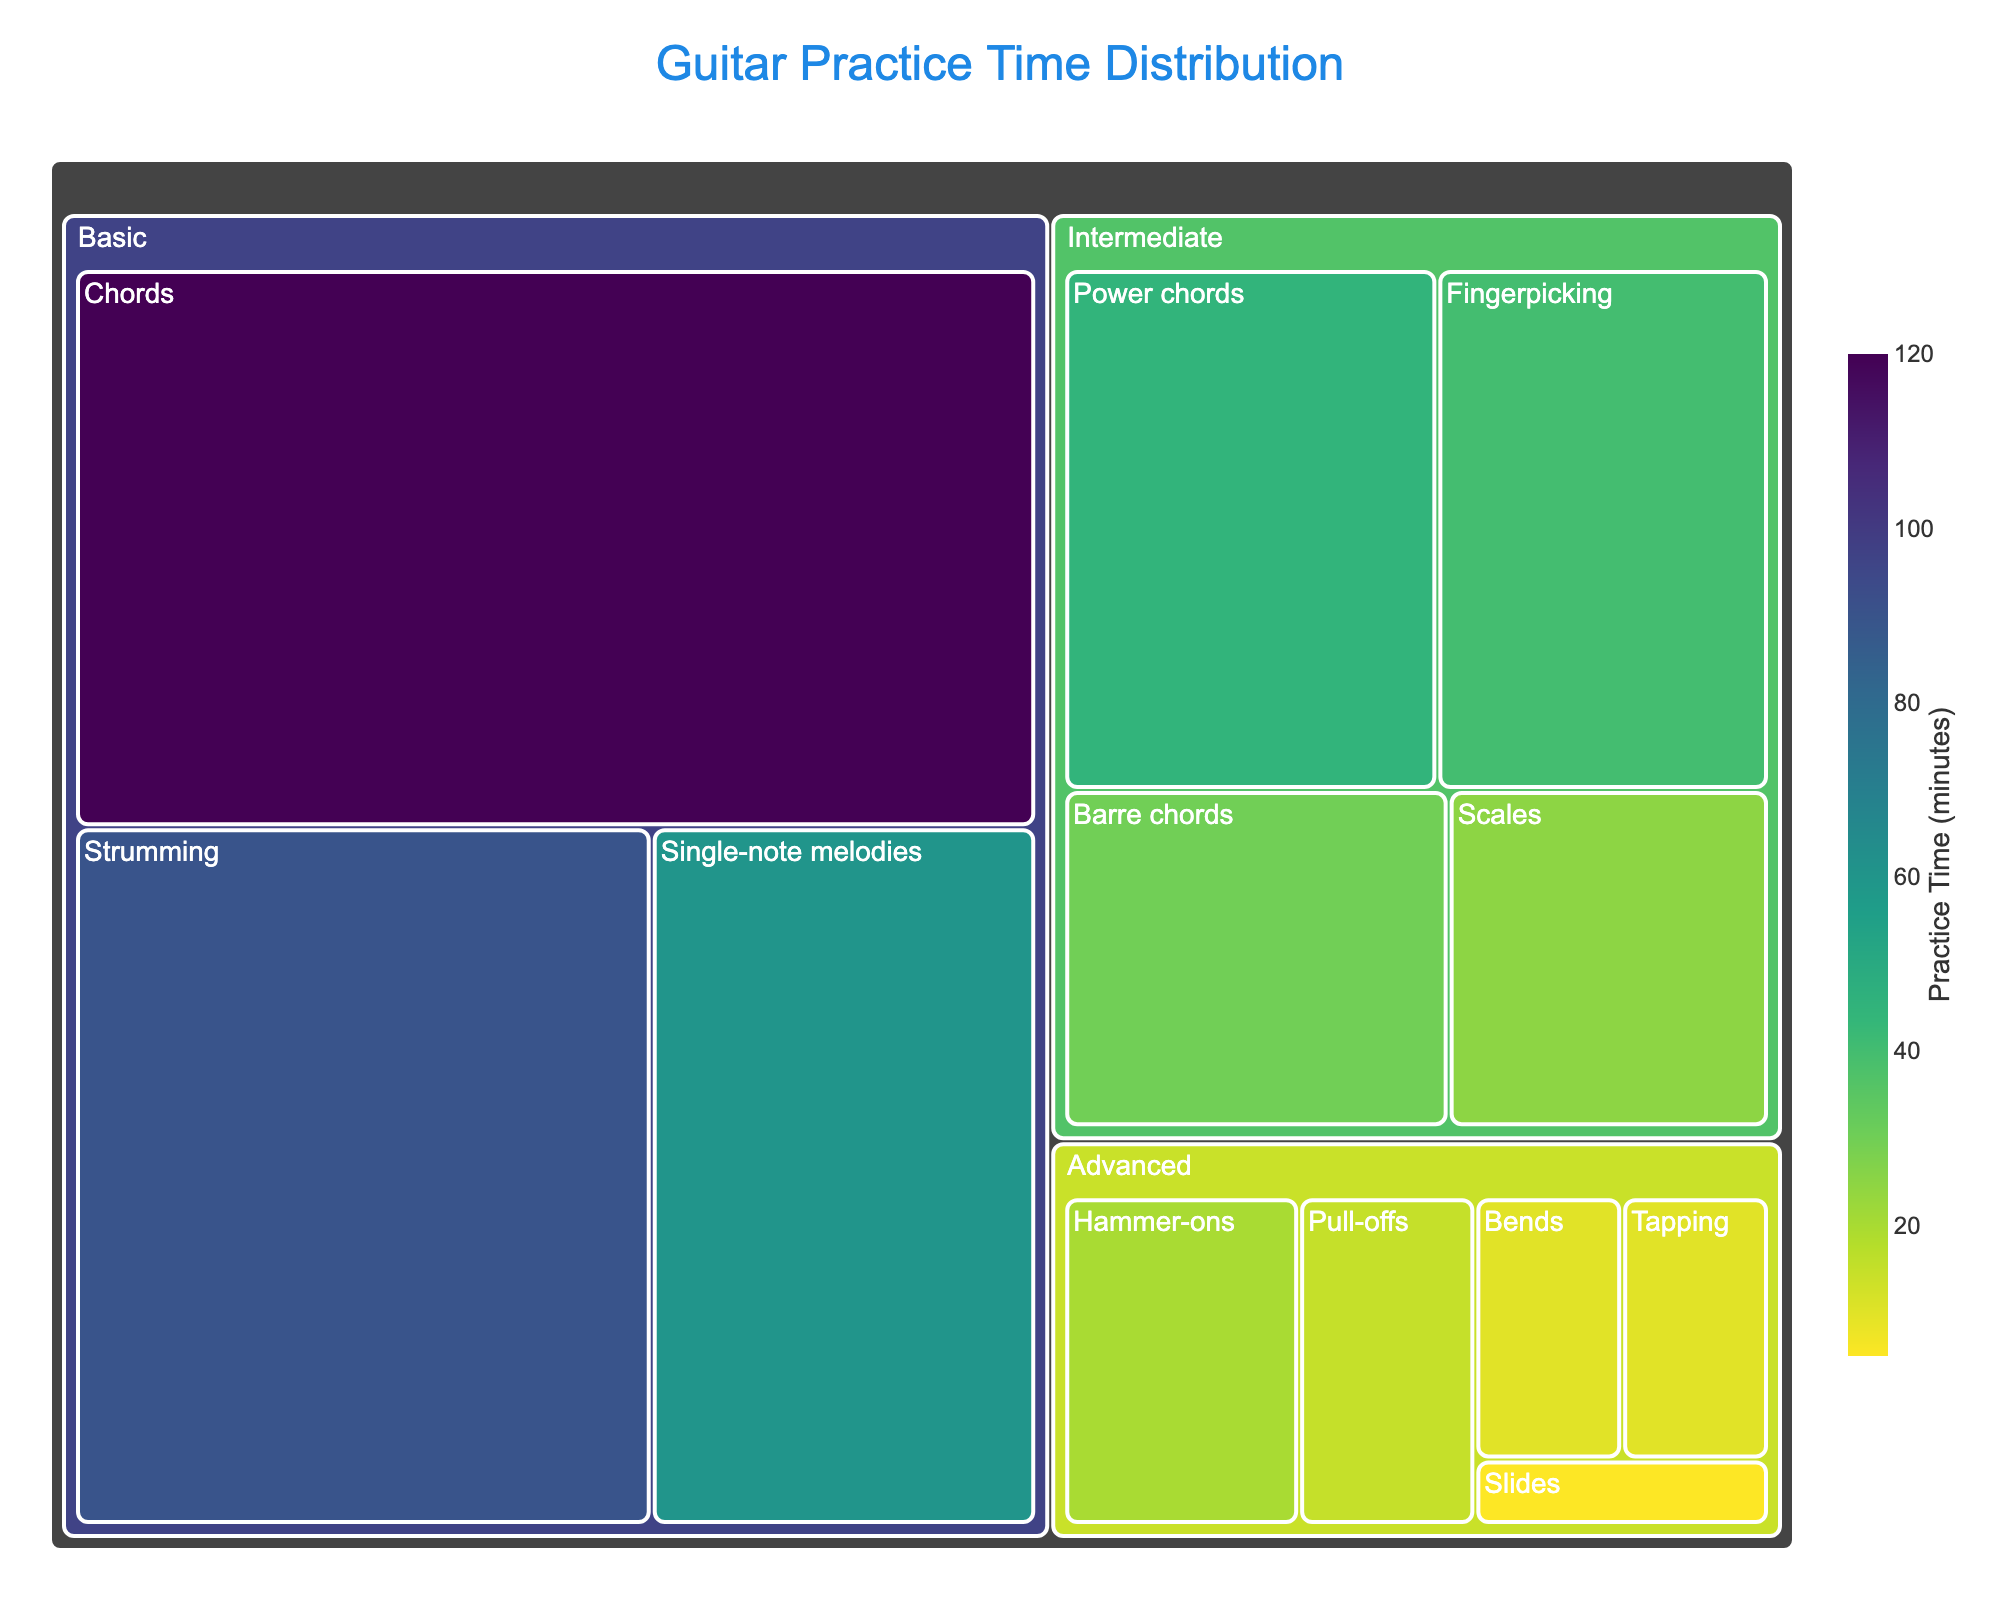Which technique has the highest practice time in the Basic category? Find the "Basic" category section in the treemap and identify the technique with the largest area that corresponds to the highest practice time. The technique is "Chords" with 120 minutes.
Answer: Chords What is the total practice time spent on Intermediate techniques? Add the practice times for all Intermediate techniques from the treemap: Power chords (45), Fingerpicking (40), Barre chords (30), and Scales (25). The total is 45 + 40 + 30 + 25 = 140 minutes.
Answer: 140 minutes Which category has the least total practice time, and what is that time? Compare the total practice times for Basic, Intermediate, and Advanced categories. Calculate the total for each. The total for Advanced is the least: Hammer-ons (20), Pull-offs (15), Tapping (10), Bends (10), and Slides (5). The total is 20 + 15 + 10 + 10 + 5 = 60 minutes.
Answer: Advanced, 60 minutes How does the practice time for Fingerpicking compare to Scales? Find Fingerpicking and Scales in the Intermediate category and compare their times. Fingerpicking has 40 minutes while Scales has 25 minutes. Fingerpicking has more practice time.
Answer: Fingerpicking has 15 minutes more than Scales What percentage of total practice time is spent on Basic techniques? Calculate the total practice time for all techniques and for Basic techniques. Total practice time = 120 + 90 + 60 + 45 + 40 + 30 + 25 + 20 + 15 + 10 + 10 + 5 = 470 minutes. Basic techniques total = 120 + 90 + 60 = 270 minutes. The percentage is (270/470) * 100 ≈ 57.45%.
Answer: 57.45% Which Advanced technique has the smallest practice time? Locate the Advanced category in the treemap and identify the technique with the smallest area. The smallest is "Slides" with 5 minutes.
Answer: Slides What is the average practice time for Intermediate techniques? Add practice times for all Intermediate techniques: 45 + 40 + 30 + 25 = 140 minutes. Divide by the number of techniques (4). The average is 140/4 = 35 minutes.
Answer: 35 minutes Which graph element visually indicates the amount of practice time for each technique? The size of each tile in the treemap visually indicates the practice time for each technique. Larger areas represent longer practice times.
Answer: Tile size Compare the practice times between Strumming and Hammer-ons. Which one is higher, and by how much? Strumming has 90 minutes and Hammer-ons have 20 minutes. Subtract Hammer-ons from Strumming, 90 - 20 = 70 minutes. Strumming has higher practice time by 70 minutes.
Answer: Strumming, 70 minutes How many techniques are categorized under Advanced? Count the number of techniques in the Advanced category listed in the treemap. There are 5 techniques: Hammer-ons, Pull-offs, Tapping, Bends, and Slides.
Answer: 5 techniques 